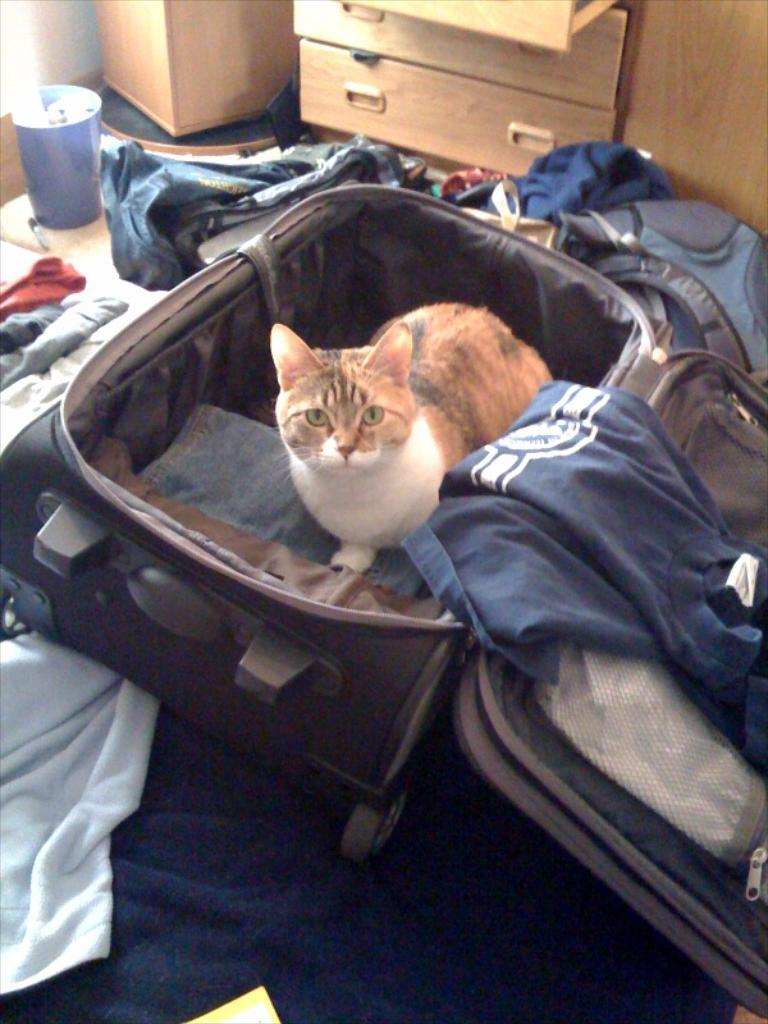What type of animal is present in the image? There is a cat in the image. Where is the cat located? The cat is inside a suitcase. What else can be seen around the suitcase? There are clothes around the suitcase. Can you identify any furniture or storage items in the image? Yes, there is a drawer in the image. How many kittens are playing with a bucket in the image? There are no kittens or buckets present in the image; it features a cat inside a suitcase and clothes around it. What type of cable is connected to the drawer in the image? There is no cable connected to the drawer in the image. 